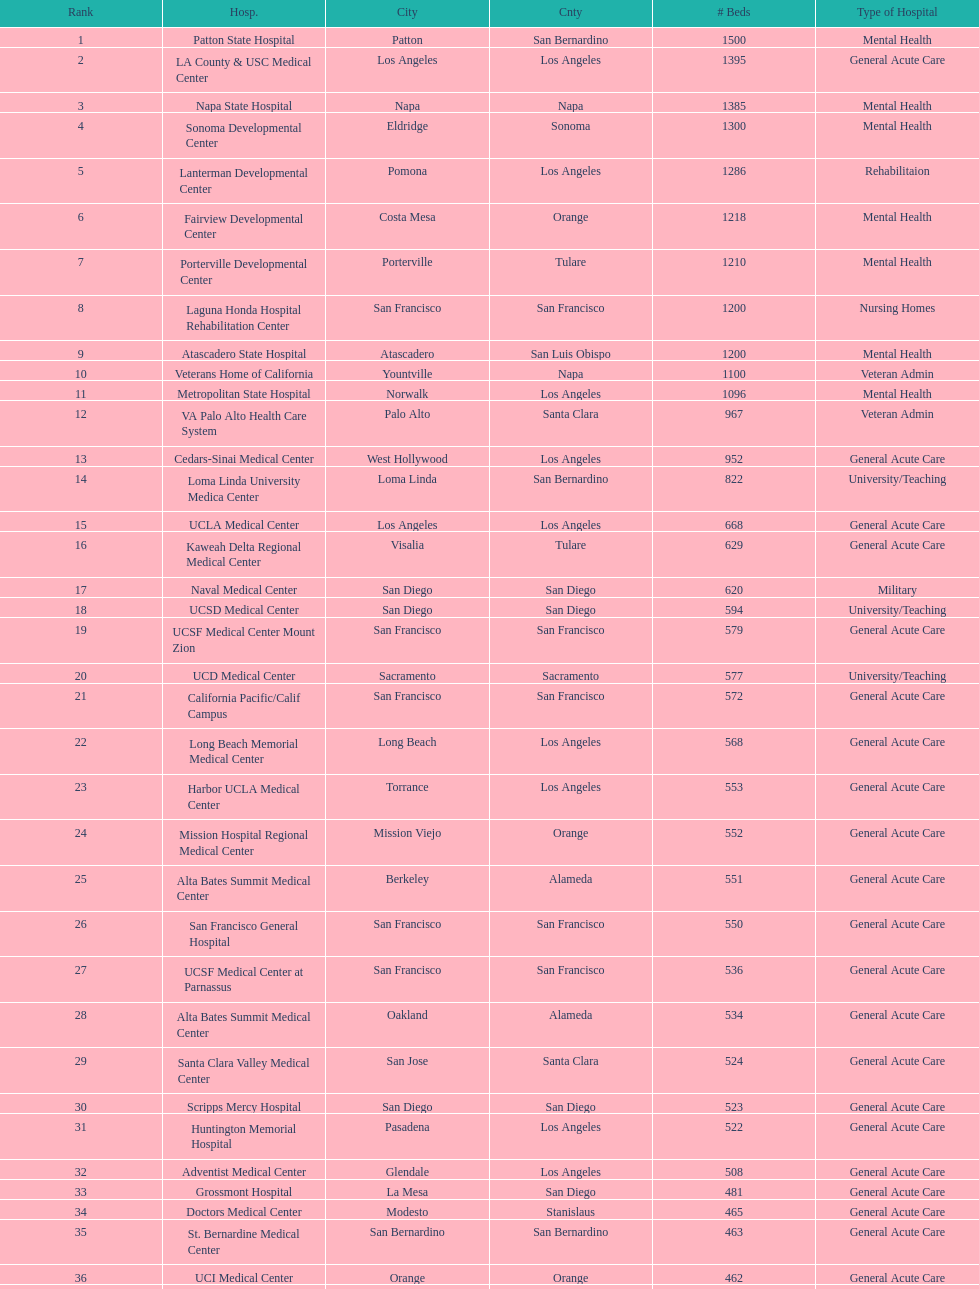How many hospital's have at least 600 beds? 17. 